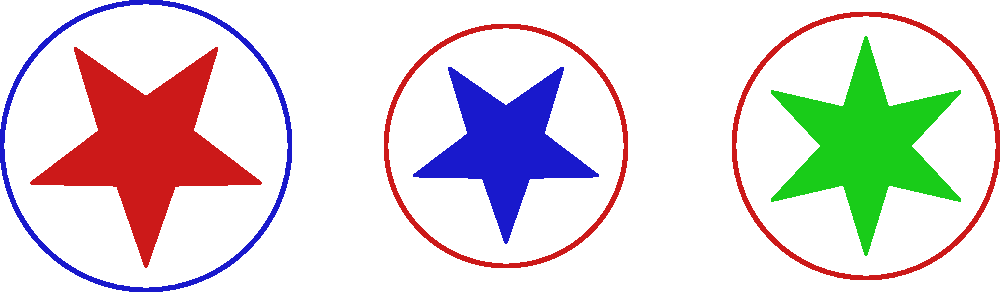Analyze the three military insignia designs shown above. Which design demonstrates the most balanced proportion between its star and circular elements? To determine the most balanced proportion between star and circular elements, we need to compare the ratio of the star's size to the circle's size for each insignia:

1. Left insignia (red star, blue circle):
   - Star radius: 1 unit
   - Circle radius: 1.2 units
   - Ratio: $1 / 1.2 = 0.833$

2. Middle insignia (blue star, red circle):
   - Star radius: 0.8 units
   - Circle radius: 1 unit
   - Ratio: $0.8 / 1 = 0.8$

3. Right insignia (green star, red circle):
   - Star radius: 0.9 units
   - Circle radius: 1.1 units
   - Ratio: $0.9 / 1.1 \approx 0.818$

The most balanced design would have a ratio closest to 1, indicating equal prominence of the star and circle elements. Comparing the ratios:

- Left insignia: 0.833
- Middle insignia: 0.8
- Right insignia: 0.818

The left insignia has the ratio closest to 1, making it the most balanced design.
Answer: Left insignia (red star, blue circle) 